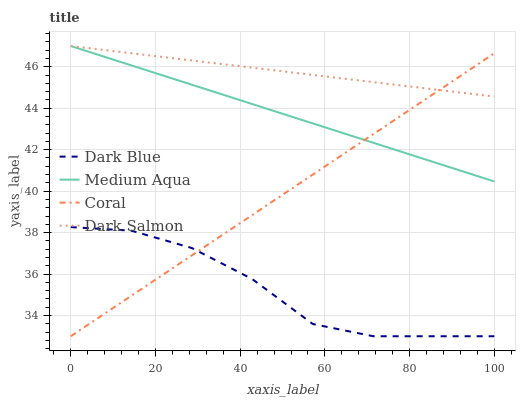Does Dark Blue have the minimum area under the curve?
Answer yes or no. Yes. Does Dark Salmon have the maximum area under the curve?
Answer yes or no. Yes. Does Coral have the minimum area under the curve?
Answer yes or no. No. Does Coral have the maximum area under the curve?
Answer yes or no. No. Is Coral the smoothest?
Answer yes or no. Yes. Is Dark Blue the roughest?
Answer yes or no. Yes. Is Medium Aqua the smoothest?
Answer yes or no. No. Is Medium Aqua the roughest?
Answer yes or no. No. Does Dark Blue have the lowest value?
Answer yes or no. Yes. Does Medium Aqua have the lowest value?
Answer yes or no. No. Does Dark Salmon have the highest value?
Answer yes or no. Yes. Does Coral have the highest value?
Answer yes or no. No. Is Dark Blue less than Medium Aqua?
Answer yes or no. Yes. Is Dark Salmon greater than Dark Blue?
Answer yes or no. Yes. Does Dark Salmon intersect Coral?
Answer yes or no. Yes. Is Dark Salmon less than Coral?
Answer yes or no. No. Is Dark Salmon greater than Coral?
Answer yes or no. No. Does Dark Blue intersect Medium Aqua?
Answer yes or no. No. 